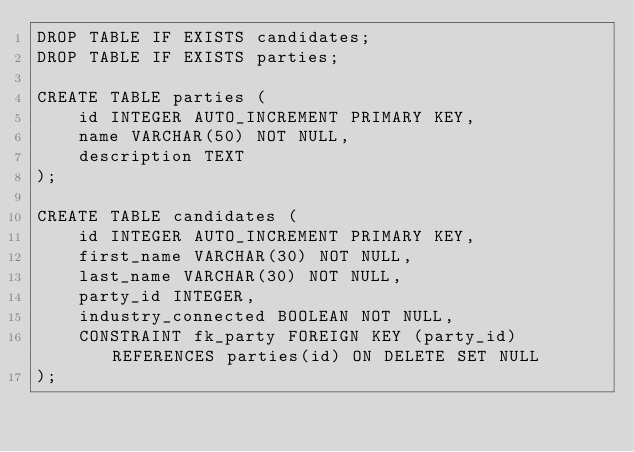Convert code to text. <code><loc_0><loc_0><loc_500><loc_500><_SQL_>DROP TABLE IF EXISTS candidates;
DROP TABLE IF EXISTS parties;

CREATE TABLE parties (
    id INTEGER AUTO_INCREMENT PRIMARY KEY,
    name VARCHAR(50) NOT NULL,
    description TEXT
);

CREATE TABLE candidates (
    id INTEGER AUTO_INCREMENT PRIMARY KEY,
    first_name VARCHAR(30) NOT NULL,
    last_name VARCHAR(30) NOT NULL,
    party_id INTEGER,
    industry_connected BOOLEAN NOT NULL,
    CONSTRAINT fk_party FOREIGN KEY (party_id) REFERENCES parties(id) ON DELETE SET NULL
);</code> 